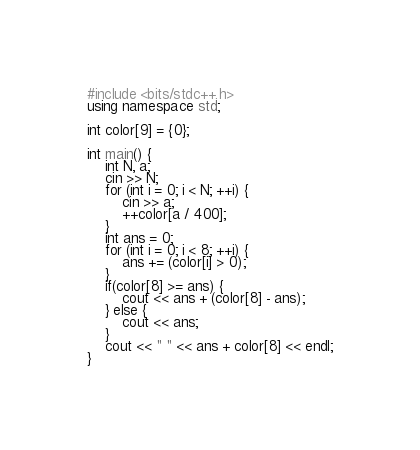Convert code to text. <code><loc_0><loc_0><loc_500><loc_500><_C++_>#include <bits/stdc++.h>
using namespace std;

int color[9] = {0};

int main() {
    int N, a;
    cin >> N;
    for (int i = 0; i < N; ++i) {
        cin >> a;
        ++color[a / 400];
    }
    int ans = 0;
    for (int i = 0; i < 8; ++i) {
        ans += (color[i] > 0);
    }
    if(color[8] >= ans) {
        cout << ans + (color[8] - ans);
    } else {
        cout << ans;
    }
    cout << " " << ans + color[8] << endl;
}</code> 